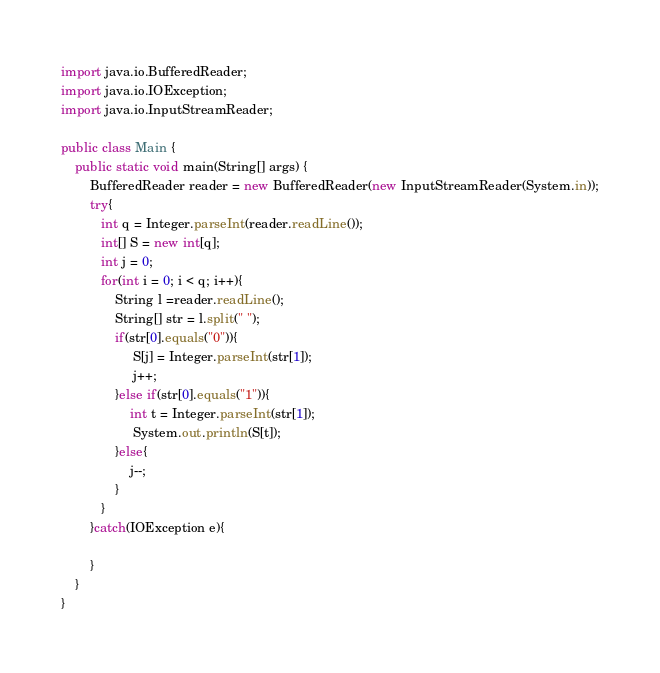Convert code to text. <code><loc_0><loc_0><loc_500><loc_500><_Java_>import java.io.BufferedReader;
import java.io.IOException;
import java.io.InputStreamReader;

public class Main {
    public static void main(String[] args) {
        BufferedReader reader = new BufferedReader(new InputStreamReader(System.in));
        try{
           int q = Integer.parseInt(reader.readLine());
           int[] S = new int[q];
           int j = 0;
           for(int i = 0; i < q; i++){
               String l =reader.readLine();
               String[] str = l.split(" ");
               if(str[0].equals("0")){
                    S[j] = Integer.parseInt(str[1]);
                    j++;
               }else if(str[0].equals("1")){
                   int t = Integer.parseInt(str[1]);
                    System.out.println(S[t]);
               }else{
                   j--;
               }
           } 
        }catch(IOException e){

        }
    }
}
</code> 